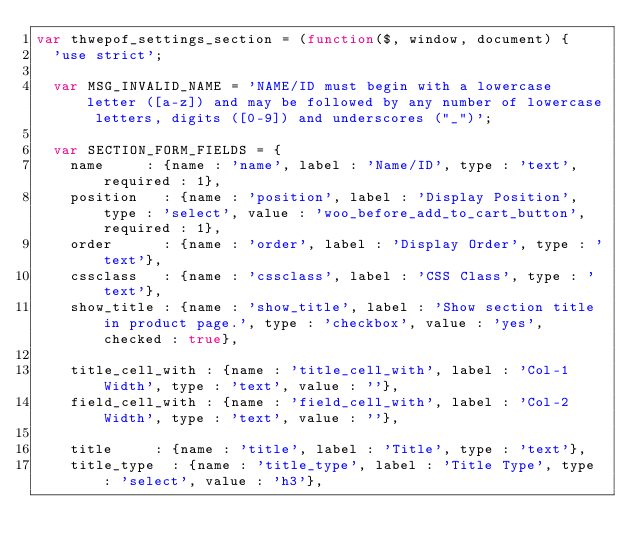<code> <loc_0><loc_0><loc_500><loc_500><_JavaScript_>var thwepof_settings_section = (function($, window, document) {
	'use strict';

	var MSG_INVALID_NAME = 'NAME/ID must begin with a lowercase letter ([a-z]) and may be followed by any number of lowercase letters, digits ([0-9]) and underscores ("_")';

	var SECTION_FORM_FIELDS = {
		name 	   : {name : 'name', label : 'Name/ID', type : 'text', required : 1},
		position   : {name : 'position', label : 'Display Position', type : 'select', value : 'woo_before_add_to_cart_button', required : 1},
		order      : {name : 'order', label : 'Display Order', type : 'text'},
		cssclass   : {name : 'cssclass', label : 'CSS Class', type : 'text'},
		show_title : {name : 'show_title', label : 'Show section title in product page.', type : 'checkbox', value : 'yes', checked : true},
		
		title_cell_with : {name : 'title_cell_with', label : 'Col-1 Width', type : 'text', value : ''},
		field_cell_with : {name : 'field_cell_with', label : 'Col-2 Width', type : 'text', value : ''},
		
		title 		: {name : 'title', label : 'Title', type : 'text'},
		title_type 	: {name : 'title_type', label : 'Title Type', type : 'select', value : 'h3'},</code> 